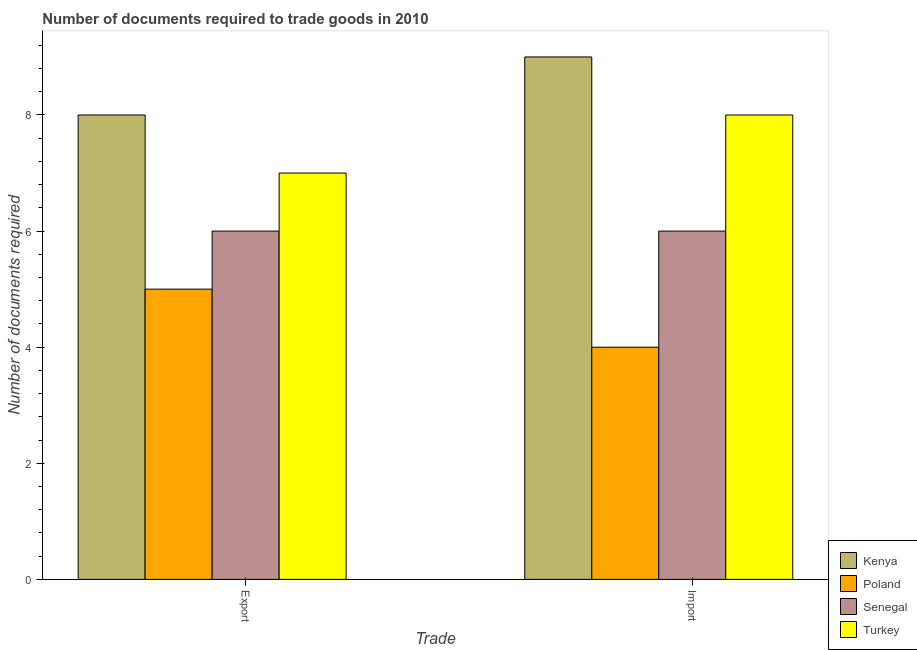How many different coloured bars are there?
Your response must be concise. 4. How many groups of bars are there?
Make the answer very short. 2. Are the number of bars per tick equal to the number of legend labels?
Offer a terse response. Yes. How many bars are there on the 1st tick from the left?
Your answer should be very brief. 4. What is the label of the 1st group of bars from the left?
Your answer should be very brief. Export. What is the number of documents required to import goods in Poland?
Provide a succinct answer. 4. Across all countries, what is the maximum number of documents required to import goods?
Your answer should be very brief. 9. Across all countries, what is the minimum number of documents required to export goods?
Provide a succinct answer. 5. In which country was the number of documents required to import goods maximum?
Provide a short and direct response. Kenya. What is the total number of documents required to import goods in the graph?
Make the answer very short. 27. What is the difference between the number of documents required to export goods in Poland and that in Kenya?
Keep it short and to the point. -3. What is the difference between the number of documents required to import goods in Poland and the number of documents required to export goods in Kenya?
Ensure brevity in your answer.  -4. What is the average number of documents required to export goods per country?
Make the answer very short. 6.5. What is the difference between the number of documents required to export goods and number of documents required to import goods in Turkey?
Keep it short and to the point. -1. In how many countries, is the number of documents required to export goods greater than 2 ?
Ensure brevity in your answer.  4. What is the ratio of the number of documents required to import goods in Turkey to that in Poland?
Give a very brief answer. 2. What does the 4th bar from the left in Export represents?
Offer a terse response. Turkey. What does the 3rd bar from the right in Export represents?
Ensure brevity in your answer.  Poland. Are all the bars in the graph horizontal?
Offer a very short reply. No. How are the legend labels stacked?
Give a very brief answer. Vertical. What is the title of the graph?
Your answer should be very brief. Number of documents required to trade goods in 2010. Does "Somalia" appear as one of the legend labels in the graph?
Offer a very short reply. No. What is the label or title of the X-axis?
Offer a very short reply. Trade. What is the label or title of the Y-axis?
Your answer should be very brief. Number of documents required. What is the Number of documents required in Kenya in Export?
Ensure brevity in your answer.  8. What is the Number of documents required of Senegal in Export?
Give a very brief answer. 6. What is the Number of documents required of Turkey in Export?
Ensure brevity in your answer.  7. What is the Number of documents required of Poland in Import?
Provide a succinct answer. 4. What is the Number of documents required in Turkey in Import?
Offer a terse response. 8. Across all Trade, what is the maximum Number of documents required of Poland?
Your answer should be compact. 5. Across all Trade, what is the maximum Number of documents required of Senegal?
Ensure brevity in your answer.  6. Across all Trade, what is the maximum Number of documents required of Turkey?
Keep it short and to the point. 8. Across all Trade, what is the minimum Number of documents required of Kenya?
Your answer should be compact. 8. What is the total Number of documents required of Poland in the graph?
Keep it short and to the point. 9. What is the total Number of documents required in Senegal in the graph?
Offer a terse response. 12. What is the total Number of documents required of Turkey in the graph?
Provide a succinct answer. 15. What is the difference between the Number of documents required in Poland in Export and that in Import?
Your answer should be compact. 1. What is the difference between the Number of documents required of Turkey in Export and that in Import?
Offer a terse response. -1. What is the difference between the Number of documents required of Kenya in Export and the Number of documents required of Poland in Import?
Keep it short and to the point. 4. What is the difference between the Number of documents required of Kenya in Export and the Number of documents required of Senegal in Import?
Your answer should be very brief. 2. What is the difference between the Number of documents required in Poland in Export and the Number of documents required in Senegal in Import?
Ensure brevity in your answer.  -1. What is the average Number of documents required of Kenya per Trade?
Provide a short and direct response. 8.5. What is the difference between the Number of documents required in Kenya and Number of documents required in Senegal in Export?
Ensure brevity in your answer.  2. What is the difference between the Number of documents required of Poland and Number of documents required of Senegal in Export?
Make the answer very short. -1. What is the difference between the Number of documents required of Poland and Number of documents required of Turkey in Export?
Ensure brevity in your answer.  -2. What is the difference between the Number of documents required in Senegal and Number of documents required in Turkey in Export?
Make the answer very short. -1. What is the difference between the Number of documents required in Kenya and Number of documents required in Poland in Import?
Keep it short and to the point. 5. What is the difference between the Number of documents required of Poland and Number of documents required of Turkey in Import?
Provide a succinct answer. -4. What is the ratio of the Number of documents required of Kenya in Export to that in Import?
Ensure brevity in your answer.  0.89. What is the ratio of the Number of documents required in Poland in Export to that in Import?
Offer a terse response. 1.25. What is the difference between the highest and the second highest Number of documents required in Senegal?
Your answer should be very brief. 0. What is the difference between the highest and the second highest Number of documents required in Turkey?
Offer a terse response. 1. What is the difference between the highest and the lowest Number of documents required in Senegal?
Make the answer very short. 0. What is the difference between the highest and the lowest Number of documents required in Turkey?
Your answer should be very brief. 1. 